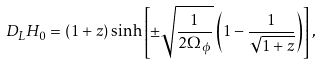<formula> <loc_0><loc_0><loc_500><loc_500>D _ { L } H _ { 0 } = ( 1 + z ) \sinh \left [ \pm \sqrt { \frac { 1 } { 2 \Omega _ { \phi } } } \left ( 1 - \frac { 1 } { \sqrt { 1 + z } } \right ) \right ] ,</formula> 